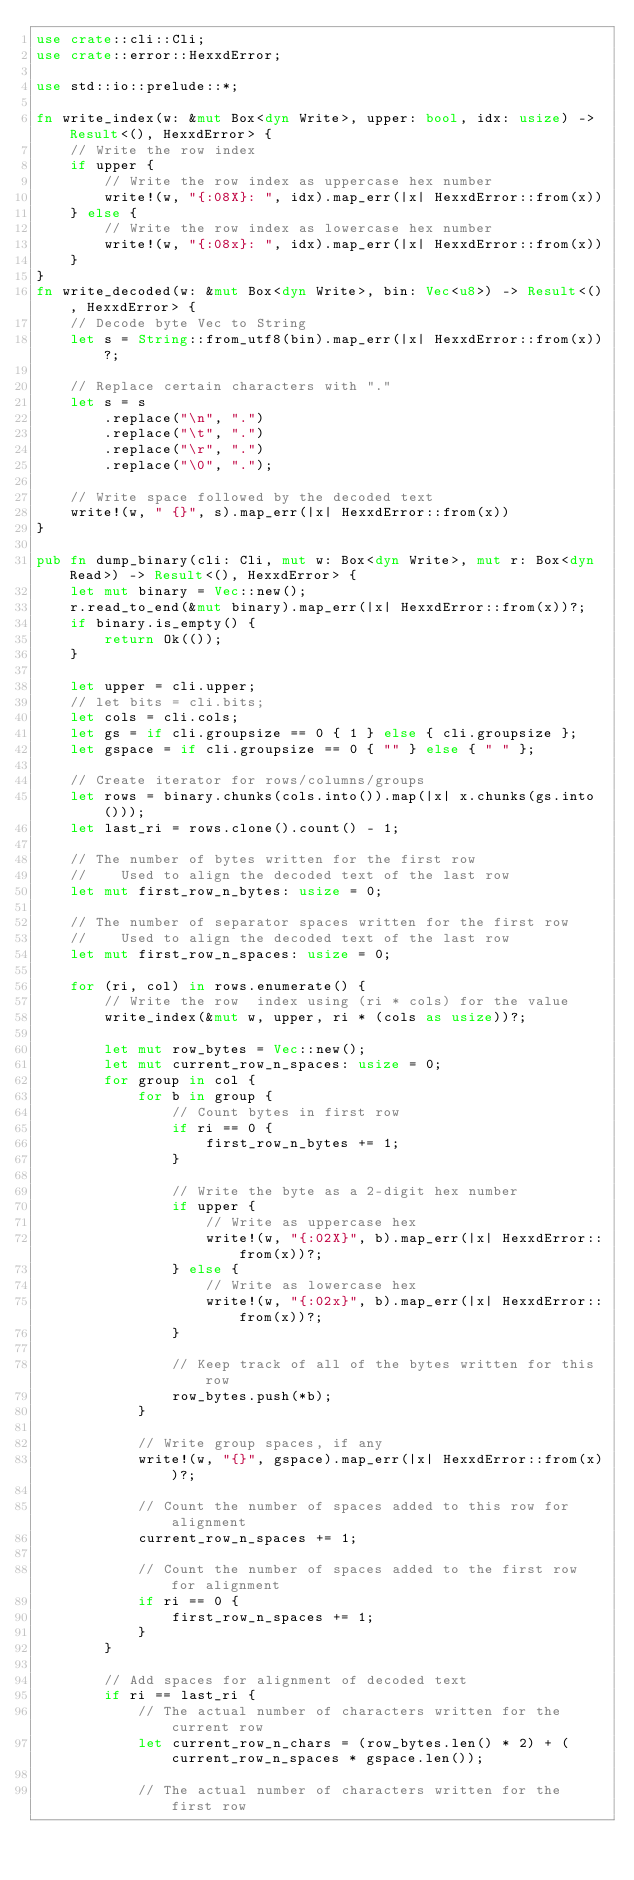<code> <loc_0><loc_0><loc_500><loc_500><_Rust_>use crate::cli::Cli;
use crate::error::HexxdError;

use std::io::prelude::*;

fn write_index(w: &mut Box<dyn Write>, upper: bool, idx: usize) -> Result<(), HexxdError> {
    // Write the row index
    if upper {
        // Write the row index as uppercase hex number
        write!(w, "{:08X}: ", idx).map_err(|x| HexxdError::from(x))
    } else {
        // Write the row index as lowercase hex number
        write!(w, "{:08x}: ", idx).map_err(|x| HexxdError::from(x))
    }
}
fn write_decoded(w: &mut Box<dyn Write>, bin: Vec<u8>) -> Result<(), HexxdError> {
    // Decode byte Vec to String
    let s = String::from_utf8(bin).map_err(|x| HexxdError::from(x))?;

    // Replace certain characters with "."
    let s = s
        .replace("\n", ".")
        .replace("\t", ".")
        .replace("\r", ".")
        .replace("\0", ".");

    // Write space followed by the decoded text
    write!(w, " {}", s).map_err(|x| HexxdError::from(x))
}

pub fn dump_binary(cli: Cli, mut w: Box<dyn Write>, mut r: Box<dyn Read>) -> Result<(), HexxdError> {
    let mut binary = Vec::new();
    r.read_to_end(&mut binary).map_err(|x| HexxdError::from(x))?;
    if binary.is_empty() {
        return Ok(());
    }

    let upper = cli.upper;
    // let bits = cli.bits;
    let cols = cli.cols;
    let gs = if cli.groupsize == 0 { 1 } else { cli.groupsize };
    let gspace = if cli.groupsize == 0 { "" } else { " " };

    // Create iterator for rows/columns/groups
    let rows = binary.chunks(cols.into()).map(|x| x.chunks(gs.into()));
    let last_ri = rows.clone().count() - 1;

    // The number of bytes written for the first row
    //    Used to align the decoded text of the last row
    let mut first_row_n_bytes: usize = 0;

    // The number of separator spaces written for the first row
    //    Used to align the decoded text of the last row
    let mut first_row_n_spaces: usize = 0;

    for (ri, col) in rows.enumerate() {
        // Write the row  index using (ri * cols) for the value
        write_index(&mut w, upper, ri * (cols as usize))?;

        let mut row_bytes = Vec::new();
        let mut current_row_n_spaces: usize = 0;
        for group in col {
            for b in group {
                // Count bytes in first row
                if ri == 0 {
                    first_row_n_bytes += 1;
                }

                // Write the byte as a 2-digit hex number
                if upper {
                    // Write as uppercase hex
                    write!(w, "{:02X}", b).map_err(|x| HexxdError::from(x))?;
                } else {
                    // Write as lowercase hex
                    write!(w, "{:02x}", b).map_err(|x| HexxdError::from(x))?;
                }

                // Keep track of all of the bytes written for this row
                row_bytes.push(*b);
            }

            // Write group spaces, if any
            write!(w, "{}", gspace).map_err(|x| HexxdError::from(x))?;

            // Count the number of spaces added to this row for alignment
            current_row_n_spaces += 1;

            // Count the number of spaces added to the first row for alignment
            if ri == 0 {
                first_row_n_spaces += 1;
            }
        }

        // Add spaces for alignment of decoded text
        if ri == last_ri {
            // The actual number of characters written for the current row
            let current_row_n_chars = (row_bytes.len() * 2) + (current_row_n_spaces * gspace.len());

            // The actual number of characters written for the first row</code> 